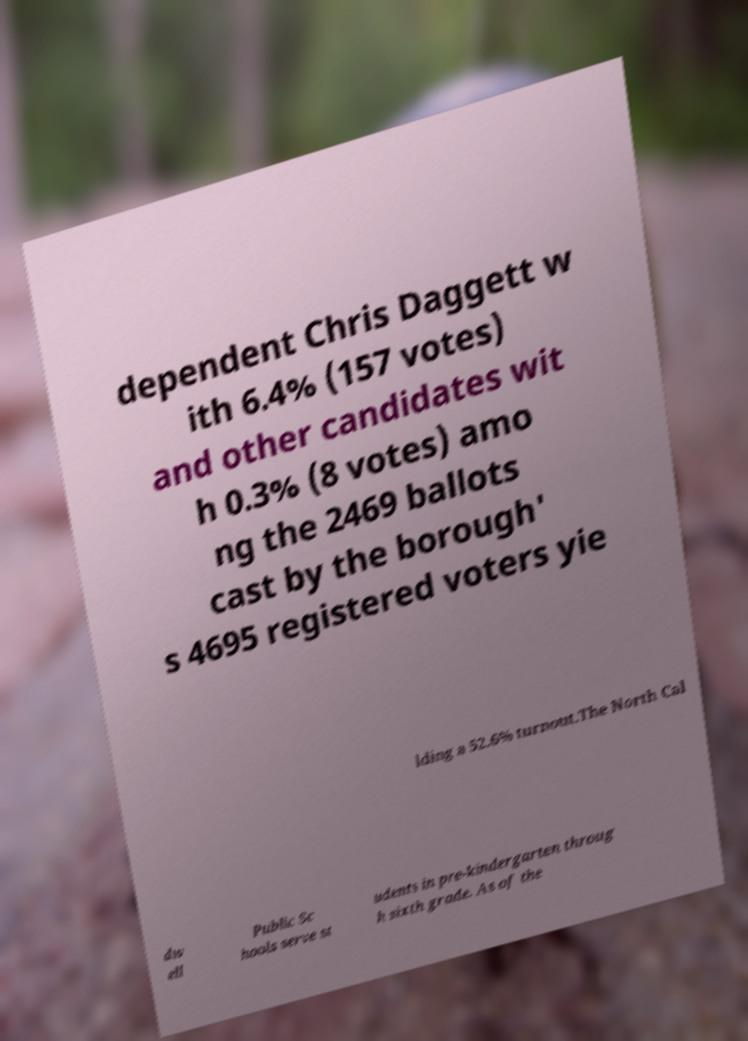There's text embedded in this image that I need extracted. Can you transcribe it verbatim? dependent Chris Daggett w ith 6.4% (157 votes) and other candidates wit h 0.3% (8 votes) amo ng the 2469 ballots cast by the borough' s 4695 registered voters yie lding a 52.6% turnout.The North Cal dw ell Public Sc hools serve st udents in pre-kindergarten throug h sixth grade. As of the 